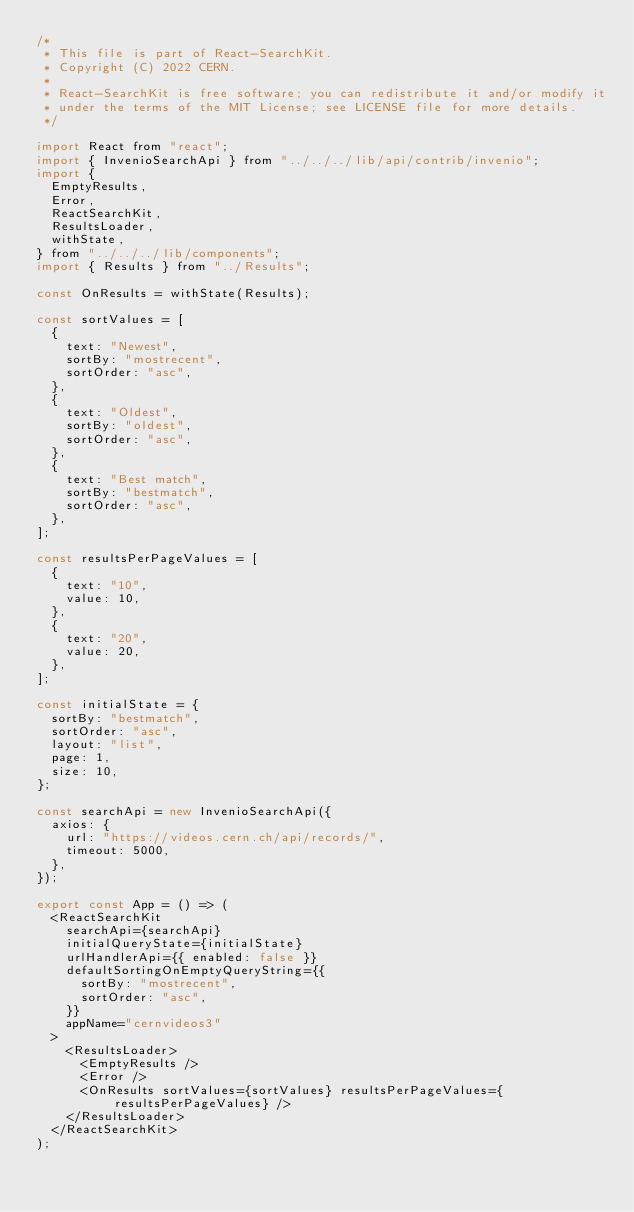Convert code to text. <code><loc_0><loc_0><loc_500><loc_500><_JavaScript_>/*
 * This file is part of React-SearchKit.
 * Copyright (C) 2022 CERN.
 *
 * React-SearchKit is free software; you can redistribute it and/or modify it
 * under the terms of the MIT License; see LICENSE file for more details.
 */

import React from "react";
import { InvenioSearchApi } from "../../../lib/api/contrib/invenio";
import {
  EmptyResults,
  Error,
  ReactSearchKit,
  ResultsLoader,
  withState,
} from "../../../lib/components";
import { Results } from "../Results";

const OnResults = withState(Results);

const sortValues = [
  {
    text: "Newest",
    sortBy: "mostrecent",
    sortOrder: "asc",
  },
  {
    text: "Oldest",
    sortBy: "oldest",
    sortOrder: "asc",
  },
  {
    text: "Best match",
    sortBy: "bestmatch",
    sortOrder: "asc",
  },
];

const resultsPerPageValues = [
  {
    text: "10",
    value: 10,
  },
  {
    text: "20",
    value: 20,
  },
];

const initialState = {
  sortBy: "bestmatch",
  sortOrder: "asc",
  layout: "list",
  page: 1,
  size: 10,
};

const searchApi = new InvenioSearchApi({
  axios: {
    url: "https://videos.cern.ch/api/records/",
    timeout: 5000,
  },
});

export const App = () => (
  <ReactSearchKit
    searchApi={searchApi}
    initialQueryState={initialState}
    urlHandlerApi={{ enabled: false }}
    defaultSortingOnEmptyQueryString={{
      sortBy: "mostrecent",
      sortOrder: "asc",
    }}
    appName="cernvideos3"
  >
    <ResultsLoader>
      <EmptyResults />
      <Error />
      <OnResults sortValues={sortValues} resultsPerPageValues={resultsPerPageValues} />
    </ResultsLoader>
  </ReactSearchKit>
);
</code> 